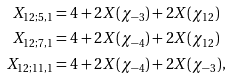Convert formula to latex. <formula><loc_0><loc_0><loc_500><loc_500>X _ { 1 2 ; 5 , 1 } & = 4 + 2 X ( \chi _ { - 3 } ) + 2 X ( \chi _ { 1 2 } ) \\ X _ { 1 2 ; 7 , 1 } & = 4 + 2 X ( \chi _ { - 4 } ) + 2 X ( \chi _ { 1 2 } ) \\ X _ { 1 2 ; 1 1 , 1 } & = 4 + 2 X ( \chi _ { - 4 } ) + 2 X ( \chi _ { - 3 } ) ,</formula> 